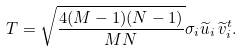Convert formula to latex. <formula><loc_0><loc_0><loc_500><loc_500>T = \sqrt { \frac { 4 ( M - 1 ) ( N - 1 ) } { M N } } \sigma _ { i } \widetilde { u } _ { i } \, \widetilde { v } _ { i } ^ { t } .</formula> 